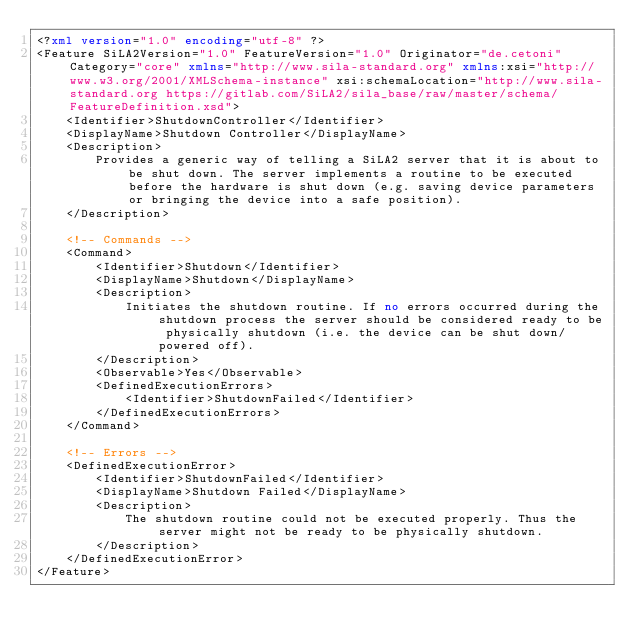Convert code to text. <code><loc_0><loc_0><loc_500><loc_500><_XML_><?xml version="1.0" encoding="utf-8" ?>
<Feature SiLA2Version="1.0" FeatureVersion="1.0" Originator="de.cetoni" Category="core" xmlns="http://www.sila-standard.org" xmlns:xsi="http://www.w3.org/2001/XMLSchema-instance" xsi:schemaLocation="http://www.sila-standard.org https://gitlab.com/SiLA2/sila_base/raw/master/schema/FeatureDefinition.xsd">
    <Identifier>ShutdownController</Identifier>
    <DisplayName>Shutdown Controller</DisplayName>
    <Description>
        Provides a generic way of telling a SiLA2 server that it is about to be shut down. The server implements a routine to be executed before the hardware is shut down (e.g. saving device parameters or bringing the device into a safe position).
    </Description>

    <!-- Commands -->
    <Command>
        <Identifier>Shutdown</Identifier>
        <DisplayName>Shutdown</DisplayName>
        <Description>
            Initiates the shutdown routine. If no errors occurred during the shutdown process the server should be considered ready to be physically shutdown (i.e. the device can be shut down/powered off).
        </Description>
        <Observable>Yes</Observable>
        <DefinedExecutionErrors>
            <Identifier>ShutdownFailed</Identifier>
        </DefinedExecutionErrors>
    </Command>

    <!-- Errors -->
    <DefinedExecutionError>
        <Identifier>ShutdownFailed</Identifier>
        <DisplayName>Shutdown Failed</DisplayName>
        <Description>
            The shutdown routine could not be executed properly. Thus the server might not be ready to be physically shutdown.
        </Description>
    </DefinedExecutionError>
</Feature>
</code> 